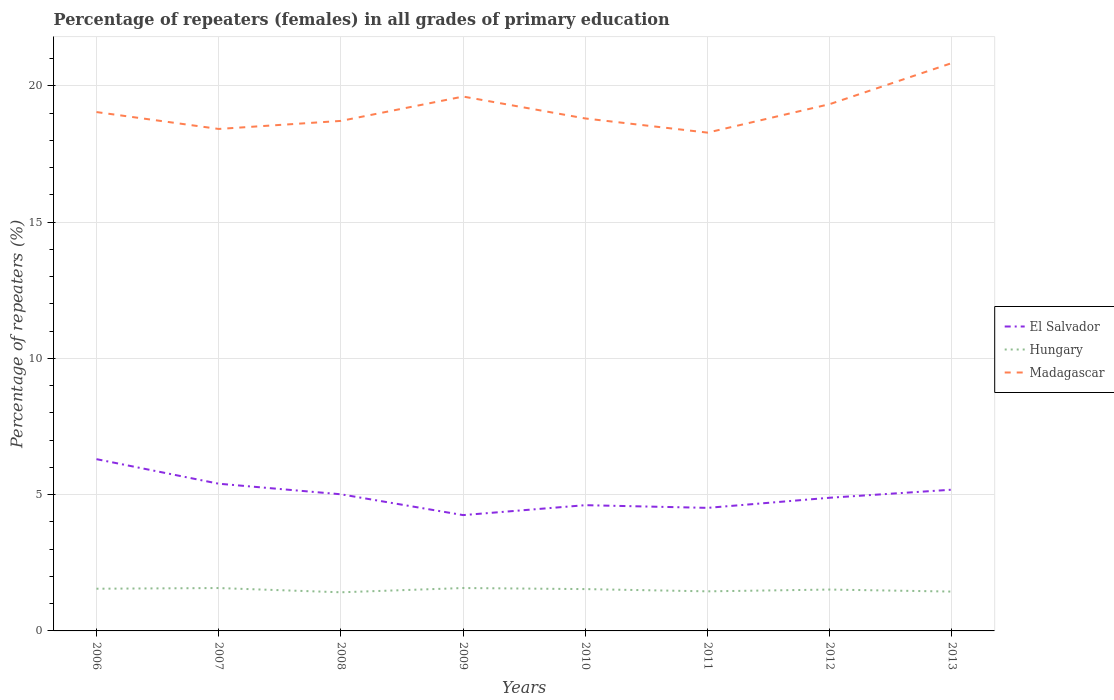Across all years, what is the maximum percentage of repeaters (females) in Hungary?
Provide a succinct answer. 1.42. In which year was the percentage of repeaters (females) in Madagascar maximum?
Give a very brief answer. 2011. What is the total percentage of repeaters (females) in El Salvador in the graph?
Your answer should be compact. 0.79. What is the difference between the highest and the second highest percentage of repeaters (females) in Hungary?
Your answer should be very brief. 0.16. Does the graph contain grids?
Offer a terse response. Yes. Where does the legend appear in the graph?
Make the answer very short. Center right. What is the title of the graph?
Give a very brief answer. Percentage of repeaters (females) in all grades of primary education. What is the label or title of the X-axis?
Give a very brief answer. Years. What is the label or title of the Y-axis?
Make the answer very short. Percentage of repeaters (%). What is the Percentage of repeaters (%) of El Salvador in 2006?
Provide a succinct answer. 6.3. What is the Percentage of repeaters (%) of Hungary in 2006?
Make the answer very short. 1.55. What is the Percentage of repeaters (%) of Madagascar in 2006?
Your answer should be very brief. 19.04. What is the Percentage of repeaters (%) of El Salvador in 2007?
Provide a succinct answer. 5.4. What is the Percentage of repeaters (%) of Hungary in 2007?
Provide a succinct answer. 1.57. What is the Percentage of repeaters (%) of Madagascar in 2007?
Your answer should be very brief. 18.42. What is the Percentage of repeaters (%) of El Salvador in 2008?
Give a very brief answer. 5.01. What is the Percentage of repeaters (%) of Hungary in 2008?
Offer a very short reply. 1.42. What is the Percentage of repeaters (%) in Madagascar in 2008?
Your answer should be compact. 18.71. What is the Percentage of repeaters (%) of El Salvador in 2009?
Keep it short and to the point. 4.25. What is the Percentage of repeaters (%) in Hungary in 2009?
Your answer should be very brief. 1.57. What is the Percentage of repeaters (%) of Madagascar in 2009?
Your answer should be very brief. 19.61. What is the Percentage of repeaters (%) of El Salvador in 2010?
Offer a terse response. 4.61. What is the Percentage of repeaters (%) in Hungary in 2010?
Ensure brevity in your answer.  1.53. What is the Percentage of repeaters (%) in Madagascar in 2010?
Keep it short and to the point. 18.8. What is the Percentage of repeaters (%) of El Salvador in 2011?
Provide a short and direct response. 4.52. What is the Percentage of repeaters (%) of Hungary in 2011?
Offer a terse response. 1.45. What is the Percentage of repeaters (%) in Madagascar in 2011?
Ensure brevity in your answer.  18.28. What is the Percentage of repeaters (%) of El Salvador in 2012?
Ensure brevity in your answer.  4.89. What is the Percentage of repeaters (%) in Hungary in 2012?
Offer a very short reply. 1.52. What is the Percentage of repeaters (%) in Madagascar in 2012?
Make the answer very short. 19.33. What is the Percentage of repeaters (%) in El Salvador in 2013?
Your answer should be compact. 5.18. What is the Percentage of repeaters (%) in Hungary in 2013?
Your answer should be compact. 1.44. What is the Percentage of repeaters (%) in Madagascar in 2013?
Offer a very short reply. 20.84. Across all years, what is the maximum Percentage of repeaters (%) in El Salvador?
Your answer should be very brief. 6.3. Across all years, what is the maximum Percentage of repeaters (%) of Hungary?
Ensure brevity in your answer.  1.57. Across all years, what is the maximum Percentage of repeaters (%) in Madagascar?
Offer a terse response. 20.84. Across all years, what is the minimum Percentage of repeaters (%) in El Salvador?
Give a very brief answer. 4.25. Across all years, what is the minimum Percentage of repeaters (%) in Hungary?
Give a very brief answer. 1.42. Across all years, what is the minimum Percentage of repeaters (%) of Madagascar?
Ensure brevity in your answer.  18.28. What is the total Percentage of repeaters (%) in El Salvador in the graph?
Provide a short and direct response. 40.17. What is the total Percentage of repeaters (%) of Hungary in the graph?
Provide a short and direct response. 12.06. What is the total Percentage of repeaters (%) of Madagascar in the graph?
Provide a succinct answer. 153.04. What is the difference between the Percentage of repeaters (%) of El Salvador in 2006 and that in 2007?
Your answer should be very brief. 0.9. What is the difference between the Percentage of repeaters (%) of Hungary in 2006 and that in 2007?
Your answer should be very brief. -0.02. What is the difference between the Percentage of repeaters (%) in Madagascar in 2006 and that in 2007?
Ensure brevity in your answer.  0.62. What is the difference between the Percentage of repeaters (%) of El Salvador in 2006 and that in 2008?
Your response must be concise. 1.29. What is the difference between the Percentage of repeaters (%) in Hungary in 2006 and that in 2008?
Your answer should be very brief. 0.13. What is the difference between the Percentage of repeaters (%) in Madagascar in 2006 and that in 2008?
Your answer should be very brief. 0.32. What is the difference between the Percentage of repeaters (%) in El Salvador in 2006 and that in 2009?
Your answer should be compact. 2.05. What is the difference between the Percentage of repeaters (%) in Hungary in 2006 and that in 2009?
Offer a very short reply. -0.03. What is the difference between the Percentage of repeaters (%) in Madagascar in 2006 and that in 2009?
Your response must be concise. -0.57. What is the difference between the Percentage of repeaters (%) in El Salvador in 2006 and that in 2010?
Make the answer very short. 1.69. What is the difference between the Percentage of repeaters (%) of Hungary in 2006 and that in 2010?
Ensure brevity in your answer.  0.01. What is the difference between the Percentage of repeaters (%) of Madagascar in 2006 and that in 2010?
Make the answer very short. 0.23. What is the difference between the Percentage of repeaters (%) of El Salvador in 2006 and that in 2011?
Offer a terse response. 1.79. What is the difference between the Percentage of repeaters (%) of Hungary in 2006 and that in 2011?
Offer a terse response. 0.1. What is the difference between the Percentage of repeaters (%) of Madagascar in 2006 and that in 2011?
Give a very brief answer. 0.75. What is the difference between the Percentage of repeaters (%) in El Salvador in 2006 and that in 2012?
Keep it short and to the point. 1.42. What is the difference between the Percentage of repeaters (%) in Hungary in 2006 and that in 2012?
Offer a very short reply. 0.03. What is the difference between the Percentage of repeaters (%) of Madagascar in 2006 and that in 2012?
Your answer should be compact. -0.29. What is the difference between the Percentage of repeaters (%) in El Salvador in 2006 and that in 2013?
Give a very brief answer. 1.12. What is the difference between the Percentage of repeaters (%) in Hungary in 2006 and that in 2013?
Your answer should be compact. 0.11. What is the difference between the Percentage of repeaters (%) of Madagascar in 2006 and that in 2013?
Provide a succinct answer. -1.8. What is the difference between the Percentage of repeaters (%) of El Salvador in 2007 and that in 2008?
Give a very brief answer. 0.39. What is the difference between the Percentage of repeaters (%) in Hungary in 2007 and that in 2008?
Your answer should be compact. 0.16. What is the difference between the Percentage of repeaters (%) of Madagascar in 2007 and that in 2008?
Your answer should be very brief. -0.3. What is the difference between the Percentage of repeaters (%) in El Salvador in 2007 and that in 2009?
Make the answer very short. 1.15. What is the difference between the Percentage of repeaters (%) of Hungary in 2007 and that in 2009?
Give a very brief answer. -0. What is the difference between the Percentage of repeaters (%) in Madagascar in 2007 and that in 2009?
Provide a succinct answer. -1.19. What is the difference between the Percentage of repeaters (%) of El Salvador in 2007 and that in 2010?
Offer a terse response. 0.79. What is the difference between the Percentage of repeaters (%) of Hungary in 2007 and that in 2010?
Give a very brief answer. 0.04. What is the difference between the Percentage of repeaters (%) of Madagascar in 2007 and that in 2010?
Offer a terse response. -0.38. What is the difference between the Percentage of repeaters (%) in El Salvador in 2007 and that in 2011?
Keep it short and to the point. 0.89. What is the difference between the Percentage of repeaters (%) of Hungary in 2007 and that in 2011?
Ensure brevity in your answer.  0.12. What is the difference between the Percentage of repeaters (%) in Madagascar in 2007 and that in 2011?
Provide a short and direct response. 0.13. What is the difference between the Percentage of repeaters (%) of El Salvador in 2007 and that in 2012?
Give a very brief answer. 0.51. What is the difference between the Percentage of repeaters (%) in Hungary in 2007 and that in 2012?
Provide a succinct answer. 0.06. What is the difference between the Percentage of repeaters (%) in Madagascar in 2007 and that in 2012?
Make the answer very short. -0.91. What is the difference between the Percentage of repeaters (%) in El Salvador in 2007 and that in 2013?
Your answer should be compact. 0.22. What is the difference between the Percentage of repeaters (%) of Hungary in 2007 and that in 2013?
Ensure brevity in your answer.  0.13. What is the difference between the Percentage of repeaters (%) in Madagascar in 2007 and that in 2013?
Give a very brief answer. -2.42. What is the difference between the Percentage of repeaters (%) of El Salvador in 2008 and that in 2009?
Provide a succinct answer. 0.76. What is the difference between the Percentage of repeaters (%) of Hungary in 2008 and that in 2009?
Your answer should be compact. -0.16. What is the difference between the Percentage of repeaters (%) in Madagascar in 2008 and that in 2009?
Offer a terse response. -0.89. What is the difference between the Percentage of repeaters (%) of El Salvador in 2008 and that in 2010?
Offer a terse response. 0.4. What is the difference between the Percentage of repeaters (%) of Hungary in 2008 and that in 2010?
Offer a very short reply. -0.12. What is the difference between the Percentage of repeaters (%) in Madagascar in 2008 and that in 2010?
Provide a short and direct response. -0.09. What is the difference between the Percentage of repeaters (%) of El Salvador in 2008 and that in 2011?
Your answer should be compact. 0.5. What is the difference between the Percentage of repeaters (%) in Hungary in 2008 and that in 2011?
Provide a short and direct response. -0.04. What is the difference between the Percentage of repeaters (%) of Madagascar in 2008 and that in 2011?
Your answer should be very brief. 0.43. What is the difference between the Percentage of repeaters (%) of El Salvador in 2008 and that in 2012?
Provide a short and direct response. 0.13. What is the difference between the Percentage of repeaters (%) of Hungary in 2008 and that in 2012?
Provide a succinct answer. -0.1. What is the difference between the Percentage of repeaters (%) in Madagascar in 2008 and that in 2012?
Make the answer very short. -0.61. What is the difference between the Percentage of repeaters (%) in El Salvador in 2008 and that in 2013?
Offer a terse response. -0.17. What is the difference between the Percentage of repeaters (%) of Hungary in 2008 and that in 2013?
Your response must be concise. -0.03. What is the difference between the Percentage of repeaters (%) of Madagascar in 2008 and that in 2013?
Offer a terse response. -2.12. What is the difference between the Percentage of repeaters (%) in El Salvador in 2009 and that in 2010?
Make the answer very short. -0.36. What is the difference between the Percentage of repeaters (%) of Hungary in 2009 and that in 2010?
Make the answer very short. 0.04. What is the difference between the Percentage of repeaters (%) in Madagascar in 2009 and that in 2010?
Keep it short and to the point. 0.8. What is the difference between the Percentage of repeaters (%) in El Salvador in 2009 and that in 2011?
Keep it short and to the point. -0.27. What is the difference between the Percentage of repeaters (%) in Hungary in 2009 and that in 2011?
Your answer should be very brief. 0.12. What is the difference between the Percentage of repeaters (%) of Madagascar in 2009 and that in 2011?
Provide a short and direct response. 1.32. What is the difference between the Percentage of repeaters (%) of El Salvador in 2009 and that in 2012?
Provide a succinct answer. -0.64. What is the difference between the Percentage of repeaters (%) of Hungary in 2009 and that in 2012?
Offer a very short reply. 0.06. What is the difference between the Percentage of repeaters (%) in Madagascar in 2009 and that in 2012?
Make the answer very short. 0.28. What is the difference between the Percentage of repeaters (%) of El Salvador in 2009 and that in 2013?
Offer a very short reply. -0.93. What is the difference between the Percentage of repeaters (%) of Hungary in 2009 and that in 2013?
Give a very brief answer. 0.13. What is the difference between the Percentage of repeaters (%) of Madagascar in 2009 and that in 2013?
Your response must be concise. -1.23. What is the difference between the Percentage of repeaters (%) in El Salvador in 2010 and that in 2011?
Your response must be concise. 0.1. What is the difference between the Percentage of repeaters (%) of Hungary in 2010 and that in 2011?
Your answer should be very brief. 0.08. What is the difference between the Percentage of repeaters (%) of Madagascar in 2010 and that in 2011?
Offer a terse response. 0.52. What is the difference between the Percentage of repeaters (%) in El Salvador in 2010 and that in 2012?
Provide a short and direct response. -0.27. What is the difference between the Percentage of repeaters (%) of Hungary in 2010 and that in 2012?
Offer a terse response. 0.02. What is the difference between the Percentage of repeaters (%) of Madagascar in 2010 and that in 2012?
Make the answer very short. -0.53. What is the difference between the Percentage of repeaters (%) of El Salvador in 2010 and that in 2013?
Your answer should be very brief. -0.57. What is the difference between the Percentage of repeaters (%) of Hungary in 2010 and that in 2013?
Offer a very short reply. 0.09. What is the difference between the Percentage of repeaters (%) of Madagascar in 2010 and that in 2013?
Your answer should be very brief. -2.03. What is the difference between the Percentage of repeaters (%) in El Salvador in 2011 and that in 2012?
Provide a short and direct response. -0.37. What is the difference between the Percentage of repeaters (%) in Hungary in 2011 and that in 2012?
Offer a very short reply. -0.07. What is the difference between the Percentage of repeaters (%) of Madagascar in 2011 and that in 2012?
Offer a terse response. -1.05. What is the difference between the Percentage of repeaters (%) of El Salvador in 2011 and that in 2013?
Make the answer very short. -0.67. What is the difference between the Percentage of repeaters (%) in Hungary in 2011 and that in 2013?
Provide a short and direct response. 0.01. What is the difference between the Percentage of repeaters (%) of Madagascar in 2011 and that in 2013?
Keep it short and to the point. -2.55. What is the difference between the Percentage of repeaters (%) in El Salvador in 2012 and that in 2013?
Provide a short and direct response. -0.3. What is the difference between the Percentage of repeaters (%) of Hungary in 2012 and that in 2013?
Offer a very short reply. 0.07. What is the difference between the Percentage of repeaters (%) in Madagascar in 2012 and that in 2013?
Keep it short and to the point. -1.51. What is the difference between the Percentage of repeaters (%) in El Salvador in 2006 and the Percentage of repeaters (%) in Hungary in 2007?
Your answer should be very brief. 4.73. What is the difference between the Percentage of repeaters (%) of El Salvador in 2006 and the Percentage of repeaters (%) of Madagascar in 2007?
Your answer should be compact. -12.12. What is the difference between the Percentage of repeaters (%) of Hungary in 2006 and the Percentage of repeaters (%) of Madagascar in 2007?
Your answer should be very brief. -16.87. What is the difference between the Percentage of repeaters (%) in El Salvador in 2006 and the Percentage of repeaters (%) in Hungary in 2008?
Make the answer very short. 4.89. What is the difference between the Percentage of repeaters (%) in El Salvador in 2006 and the Percentage of repeaters (%) in Madagascar in 2008?
Your answer should be very brief. -12.41. What is the difference between the Percentage of repeaters (%) in Hungary in 2006 and the Percentage of repeaters (%) in Madagascar in 2008?
Your response must be concise. -17.17. What is the difference between the Percentage of repeaters (%) of El Salvador in 2006 and the Percentage of repeaters (%) of Hungary in 2009?
Make the answer very short. 4.73. What is the difference between the Percentage of repeaters (%) of El Salvador in 2006 and the Percentage of repeaters (%) of Madagascar in 2009?
Offer a terse response. -13.31. What is the difference between the Percentage of repeaters (%) of Hungary in 2006 and the Percentage of repeaters (%) of Madagascar in 2009?
Keep it short and to the point. -18.06. What is the difference between the Percentage of repeaters (%) in El Salvador in 2006 and the Percentage of repeaters (%) in Hungary in 2010?
Keep it short and to the point. 4.77. What is the difference between the Percentage of repeaters (%) of El Salvador in 2006 and the Percentage of repeaters (%) of Madagascar in 2010?
Offer a very short reply. -12.5. What is the difference between the Percentage of repeaters (%) of Hungary in 2006 and the Percentage of repeaters (%) of Madagascar in 2010?
Your response must be concise. -17.26. What is the difference between the Percentage of repeaters (%) of El Salvador in 2006 and the Percentage of repeaters (%) of Hungary in 2011?
Ensure brevity in your answer.  4.85. What is the difference between the Percentage of repeaters (%) in El Salvador in 2006 and the Percentage of repeaters (%) in Madagascar in 2011?
Offer a terse response. -11.98. What is the difference between the Percentage of repeaters (%) of Hungary in 2006 and the Percentage of repeaters (%) of Madagascar in 2011?
Give a very brief answer. -16.74. What is the difference between the Percentage of repeaters (%) in El Salvador in 2006 and the Percentage of repeaters (%) in Hungary in 2012?
Offer a very short reply. 4.78. What is the difference between the Percentage of repeaters (%) of El Salvador in 2006 and the Percentage of repeaters (%) of Madagascar in 2012?
Offer a very short reply. -13.03. What is the difference between the Percentage of repeaters (%) in Hungary in 2006 and the Percentage of repeaters (%) in Madagascar in 2012?
Provide a short and direct response. -17.78. What is the difference between the Percentage of repeaters (%) in El Salvador in 2006 and the Percentage of repeaters (%) in Hungary in 2013?
Keep it short and to the point. 4.86. What is the difference between the Percentage of repeaters (%) of El Salvador in 2006 and the Percentage of repeaters (%) of Madagascar in 2013?
Offer a terse response. -14.54. What is the difference between the Percentage of repeaters (%) in Hungary in 2006 and the Percentage of repeaters (%) in Madagascar in 2013?
Make the answer very short. -19.29. What is the difference between the Percentage of repeaters (%) of El Salvador in 2007 and the Percentage of repeaters (%) of Hungary in 2008?
Your answer should be compact. 3.98. What is the difference between the Percentage of repeaters (%) in El Salvador in 2007 and the Percentage of repeaters (%) in Madagascar in 2008?
Keep it short and to the point. -13.31. What is the difference between the Percentage of repeaters (%) of Hungary in 2007 and the Percentage of repeaters (%) of Madagascar in 2008?
Keep it short and to the point. -17.14. What is the difference between the Percentage of repeaters (%) of El Salvador in 2007 and the Percentage of repeaters (%) of Hungary in 2009?
Offer a very short reply. 3.83. What is the difference between the Percentage of repeaters (%) in El Salvador in 2007 and the Percentage of repeaters (%) in Madagascar in 2009?
Ensure brevity in your answer.  -14.21. What is the difference between the Percentage of repeaters (%) of Hungary in 2007 and the Percentage of repeaters (%) of Madagascar in 2009?
Provide a succinct answer. -18.04. What is the difference between the Percentage of repeaters (%) in El Salvador in 2007 and the Percentage of repeaters (%) in Hungary in 2010?
Provide a short and direct response. 3.87. What is the difference between the Percentage of repeaters (%) of El Salvador in 2007 and the Percentage of repeaters (%) of Madagascar in 2010?
Your response must be concise. -13.4. What is the difference between the Percentage of repeaters (%) of Hungary in 2007 and the Percentage of repeaters (%) of Madagascar in 2010?
Your answer should be very brief. -17.23. What is the difference between the Percentage of repeaters (%) of El Salvador in 2007 and the Percentage of repeaters (%) of Hungary in 2011?
Your response must be concise. 3.95. What is the difference between the Percentage of repeaters (%) of El Salvador in 2007 and the Percentage of repeaters (%) of Madagascar in 2011?
Provide a succinct answer. -12.88. What is the difference between the Percentage of repeaters (%) of Hungary in 2007 and the Percentage of repeaters (%) of Madagascar in 2011?
Make the answer very short. -16.71. What is the difference between the Percentage of repeaters (%) of El Salvador in 2007 and the Percentage of repeaters (%) of Hungary in 2012?
Keep it short and to the point. 3.88. What is the difference between the Percentage of repeaters (%) in El Salvador in 2007 and the Percentage of repeaters (%) in Madagascar in 2012?
Ensure brevity in your answer.  -13.93. What is the difference between the Percentage of repeaters (%) in Hungary in 2007 and the Percentage of repeaters (%) in Madagascar in 2012?
Make the answer very short. -17.76. What is the difference between the Percentage of repeaters (%) in El Salvador in 2007 and the Percentage of repeaters (%) in Hungary in 2013?
Keep it short and to the point. 3.96. What is the difference between the Percentage of repeaters (%) in El Salvador in 2007 and the Percentage of repeaters (%) in Madagascar in 2013?
Your response must be concise. -15.44. What is the difference between the Percentage of repeaters (%) in Hungary in 2007 and the Percentage of repeaters (%) in Madagascar in 2013?
Your response must be concise. -19.26. What is the difference between the Percentage of repeaters (%) in El Salvador in 2008 and the Percentage of repeaters (%) in Hungary in 2009?
Provide a succinct answer. 3.44. What is the difference between the Percentage of repeaters (%) in El Salvador in 2008 and the Percentage of repeaters (%) in Madagascar in 2009?
Provide a short and direct response. -14.59. What is the difference between the Percentage of repeaters (%) in Hungary in 2008 and the Percentage of repeaters (%) in Madagascar in 2009?
Your answer should be very brief. -18.19. What is the difference between the Percentage of repeaters (%) of El Salvador in 2008 and the Percentage of repeaters (%) of Hungary in 2010?
Make the answer very short. 3.48. What is the difference between the Percentage of repeaters (%) of El Salvador in 2008 and the Percentage of repeaters (%) of Madagascar in 2010?
Your answer should be compact. -13.79. What is the difference between the Percentage of repeaters (%) of Hungary in 2008 and the Percentage of repeaters (%) of Madagascar in 2010?
Keep it short and to the point. -17.39. What is the difference between the Percentage of repeaters (%) in El Salvador in 2008 and the Percentage of repeaters (%) in Hungary in 2011?
Your answer should be very brief. 3.56. What is the difference between the Percentage of repeaters (%) in El Salvador in 2008 and the Percentage of repeaters (%) in Madagascar in 2011?
Your response must be concise. -13.27. What is the difference between the Percentage of repeaters (%) in Hungary in 2008 and the Percentage of repeaters (%) in Madagascar in 2011?
Ensure brevity in your answer.  -16.87. What is the difference between the Percentage of repeaters (%) of El Salvador in 2008 and the Percentage of repeaters (%) of Hungary in 2012?
Ensure brevity in your answer.  3.5. What is the difference between the Percentage of repeaters (%) in El Salvador in 2008 and the Percentage of repeaters (%) in Madagascar in 2012?
Your answer should be very brief. -14.32. What is the difference between the Percentage of repeaters (%) of Hungary in 2008 and the Percentage of repeaters (%) of Madagascar in 2012?
Provide a short and direct response. -17.91. What is the difference between the Percentage of repeaters (%) in El Salvador in 2008 and the Percentage of repeaters (%) in Hungary in 2013?
Give a very brief answer. 3.57. What is the difference between the Percentage of repeaters (%) of El Salvador in 2008 and the Percentage of repeaters (%) of Madagascar in 2013?
Give a very brief answer. -15.82. What is the difference between the Percentage of repeaters (%) of Hungary in 2008 and the Percentage of repeaters (%) of Madagascar in 2013?
Your response must be concise. -19.42. What is the difference between the Percentage of repeaters (%) in El Salvador in 2009 and the Percentage of repeaters (%) in Hungary in 2010?
Your answer should be very brief. 2.71. What is the difference between the Percentage of repeaters (%) in El Salvador in 2009 and the Percentage of repeaters (%) in Madagascar in 2010?
Provide a short and direct response. -14.55. What is the difference between the Percentage of repeaters (%) of Hungary in 2009 and the Percentage of repeaters (%) of Madagascar in 2010?
Your response must be concise. -17.23. What is the difference between the Percentage of repeaters (%) in El Salvador in 2009 and the Percentage of repeaters (%) in Hungary in 2011?
Keep it short and to the point. 2.8. What is the difference between the Percentage of repeaters (%) of El Salvador in 2009 and the Percentage of repeaters (%) of Madagascar in 2011?
Your answer should be compact. -14.03. What is the difference between the Percentage of repeaters (%) in Hungary in 2009 and the Percentage of repeaters (%) in Madagascar in 2011?
Keep it short and to the point. -16.71. What is the difference between the Percentage of repeaters (%) in El Salvador in 2009 and the Percentage of repeaters (%) in Hungary in 2012?
Your answer should be compact. 2.73. What is the difference between the Percentage of repeaters (%) of El Salvador in 2009 and the Percentage of repeaters (%) of Madagascar in 2012?
Offer a very short reply. -15.08. What is the difference between the Percentage of repeaters (%) in Hungary in 2009 and the Percentage of repeaters (%) in Madagascar in 2012?
Offer a terse response. -17.76. What is the difference between the Percentage of repeaters (%) of El Salvador in 2009 and the Percentage of repeaters (%) of Hungary in 2013?
Make the answer very short. 2.81. What is the difference between the Percentage of repeaters (%) of El Salvador in 2009 and the Percentage of repeaters (%) of Madagascar in 2013?
Provide a short and direct response. -16.59. What is the difference between the Percentage of repeaters (%) of Hungary in 2009 and the Percentage of repeaters (%) of Madagascar in 2013?
Keep it short and to the point. -19.26. What is the difference between the Percentage of repeaters (%) in El Salvador in 2010 and the Percentage of repeaters (%) in Hungary in 2011?
Offer a very short reply. 3.16. What is the difference between the Percentage of repeaters (%) in El Salvador in 2010 and the Percentage of repeaters (%) in Madagascar in 2011?
Provide a succinct answer. -13.67. What is the difference between the Percentage of repeaters (%) of Hungary in 2010 and the Percentage of repeaters (%) of Madagascar in 2011?
Provide a short and direct response. -16.75. What is the difference between the Percentage of repeaters (%) of El Salvador in 2010 and the Percentage of repeaters (%) of Hungary in 2012?
Your answer should be compact. 3.1. What is the difference between the Percentage of repeaters (%) of El Salvador in 2010 and the Percentage of repeaters (%) of Madagascar in 2012?
Offer a terse response. -14.72. What is the difference between the Percentage of repeaters (%) of Hungary in 2010 and the Percentage of repeaters (%) of Madagascar in 2012?
Make the answer very short. -17.79. What is the difference between the Percentage of repeaters (%) in El Salvador in 2010 and the Percentage of repeaters (%) in Hungary in 2013?
Your response must be concise. 3.17. What is the difference between the Percentage of repeaters (%) of El Salvador in 2010 and the Percentage of repeaters (%) of Madagascar in 2013?
Provide a short and direct response. -16.22. What is the difference between the Percentage of repeaters (%) of Hungary in 2010 and the Percentage of repeaters (%) of Madagascar in 2013?
Your response must be concise. -19.3. What is the difference between the Percentage of repeaters (%) in El Salvador in 2011 and the Percentage of repeaters (%) in Hungary in 2012?
Your response must be concise. 3. What is the difference between the Percentage of repeaters (%) of El Salvador in 2011 and the Percentage of repeaters (%) of Madagascar in 2012?
Ensure brevity in your answer.  -14.81. What is the difference between the Percentage of repeaters (%) in Hungary in 2011 and the Percentage of repeaters (%) in Madagascar in 2012?
Your answer should be compact. -17.88. What is the difference between the Percentage of repeaters (%) in El Salvador in 2011 and the Percentage of repeaters (%) in Hungary in 2013?
Make the answer very short. 3.07. What is the difference between the Percentage of repeaters (%) of El Salvador in 2011 and the Percentage of repeaters (%) of Madagascar in 2013?
Your response must be concise. -16.32. What is the difference between the Percentage of repeaters (%) of Hungary in 2011 and the Percentage of repeaters (%) of Madagascar in 2013?
Offer a terse response. -19.39. What is the difference between the Percentage of repeaters (%) in El Salvador in 2012 and the Percentage of repeaters (%) in Hungary in 2013?
Give a very brief answer. 3.44. What is the difference between the Percentage of repeaters (%) in El Salvador in 2012 and the Percentage of repeaters (%) in Madagascar in 2013?
Your answer should be compact. -15.95. What is the difference between the Percentage of repeaters (%) in Hungary in 2012 and the Percentage of repeaters (%) in Madagascar in 2013?
Provide a short and direct response. -19.32. What is the average Percentage of repeaters (%) of El Salvador per year?
Your answer should be very brief. 5.02. What is the average Percentage of repeaters (%) of Hungary per year?
Ensure brevity in your answer.  1.51. What is the average Percentage of repeaters (%) of Madagascar per year?
Offer a terse response. 19.13. In the year 2006, what is the difference between the Percentage of repeaters (%) of El Salvador and Percentage of repeaters (%) of Hungary?
Your answer should be compact. 4.75. In the year 2006, what is the difference between the Percentage of repeaters (%) in El Salvador and Percentage of repeaters (%) in Madagascar?
Keep it short and to the point. -12.74. In the year 2006, what is the difference between the Percentage of repeaters (%) of Hungary and Percentage of repeaters (%) of Madagascar?
Make the answer very short. -17.49. In the year 2007, what is the difference between the Percentage of repeaters (%) in El Salvador and Percentage of repeaters (%) in Hungary?
Offer a very short reply. 3.83. In the year 2007, what is the difference between the Percentage of repeaters (%) of El Salvador and Percentage of repeaters (%) of Madagascar?
Provide a short and direct response. -13.02. In the year 2007, what is the difference between the Percentage of repeaters (%) in Hungary and Percentage of repeaters (%) in Madagascar?
Ensure brevity in your answer.  -16.85. In the year 2008, what is the difference between the Percentage of repeaters (%) in El Salvador and Percentage of repeaters (%) in Hungary?
Provide a short and direct response. 3.6. In the year 2008, what is the difference between the Percentage of repeaters (%) in El Salvador and Percentage of repeaters (%) in Madagascar?
Your response must be concise. -13.7. In the year 2008, what is the difference between the Percentage of repeaters (%) in Hungary and Percentage of repeaters (%) in Madagascar?
Offer a terse response. -17.3. In the year 2009, what is the difference between the Percentage of repeaters (%) of El Salvador and Percentage of repeaters (%) of Hungary?
Your answer should be very brief. 2.68. In the year 2009, what is the difference between the Percentage of repeaters (%) of El Salvador and Percentage of repeaters (%) of Madagascar?
Offer a terse response. -15.36. In the year 2009, what is the difference between the Percentage of repeaters (%) of Hungary and Percentage of repeaters (%) of Madagascar?
Your answer should be very brief. -18.03. In the year 2010, what is the difference between the Percentage of repeaters (%) of El Salvador and Percentage of repeaters (%) of Hungary?
Make the answer very short. 3.08. In the year 2010, what is the difference between the Percentage of repeaters (%) in El Salvador and Percentage of repeaters (%) in Madagascar?
Keep it short and to the point. -14.19. In the year 2010, what is the difference between the Percentage of repeaters (%) of Hungary and Percentage of repeaters (%) of Madagascar?
Offer a terse response. -17.27. In the year 2011, what is the difference between the Percentage of repeaters (%) of El Salvador and Percentage of repeaters (%) of Hungary?
Ensure brevity in your answer.  3.06. In the year 2011, what is the difference between the Percentage of repeaters (%) in El Salvador and Percentage of repeaters (%) in Madagascar?
Keep it short and to the point. -13.77. In the year 2011, what is the difference between the Percentage of repeaters (%) in Hungary and Percentage of repeaters (%) in Madagascar?
Your answer should be compact. -16.83. In the year 2012, what is the difference between the Percentage of repeaters (%) of El Salvador and Percentage of repeaters (%) of Hungary?
Ensure brevity in your answer.  3.37. In the year 2012, what is the difference between the Percentage of repeaters (%) in El Salvador and Percentage of repeaters (%) in Madagascar?
Your response must be concise. -14.44. In the year 2012, what is the difference between the Percentage of repeaters (%) of Hungary and Percentage of repeaters (%) of Madagascar?
Your response must be concise. -17.81. In the year 2013, what is the difference between the Percentage of repeaters (%) of El Salvador and Percentage of repeaters (%) of Hungary?
Ensure brevity in your answer.  3.74. In the year 2013, what is the difference between the Percentage of repeaters (%) of El Salvador and Percentage of repeaters (%) of Madagascar?
Ensure brevity in your answer.  -15.66. In the year 2013, what is the difference between the Percentage of repeaters (%) of Hungary and Percentage of repeaters (%) of Madagascar?
Offer a very short reply. -19.39. What is the ratio of the Percentage of repeaters (%) of El Salvador in 2006 to that in 2007?
Offer a very short reply. 1.17. What is the ratio of the Percentage of repeaters (%) in Hungary in 2006 to that in 2007?
Ensure brevity in your answer.  0.98. What is the ratio of the Percentage of repeaters (%) in Madagascar in 2006 to that in 2007?
Your answer should be compact. 1.03. What is the ratio of the Percentage of repeaters (%) of El Salvador in 2006 to that in 2008?
Offer a very short reply. 1.26. What is the ratio of the Percentage of repeaters (%) of Hungary in 2006 to that in 2008?
Keep it short and to the point. 1.09. What is the ratio of the Percentage of repeaters (%) of Madagascar in 2006 to that in 2008?
Make the answer very short. 1.02. What is the ratio of the Percentage of repeaters (%) in El Salvador in 2006 to that in 2009?
Make the answer very short. 1.48. What is the ratio of the Percentage of repeaters (%) in Hungary in 2006 to that in 2009?
Make the answer very short. 0.98. What is the ratio of the Percentage of repeaters (%) of Madagascar in 2006 to that in 2009?
Provide a short and direct response. 0.97. What is the ratio of the Percentage of repeaters (%) in El Salvador in 2006 to that in 2010?
Offer a very short reply. 1.37. What is the ratio of the Percentage of repeaters (%) of Madagascar in 2006 to that in 2010?
Give a very brief answer. 1.01. What is the ratio of the Percentage of repeaters (%) in El Salvador in 2006 to that in 2011?
Keep it short and to the point. 1.4. What is the ratio of the Percentage of repeaters (%) in Hungary in 2006 to that in 2011?
Offer a terse response. 1.07. What is the ratio of the Percentage of repeaters (%) in Madagascar in 2006 to that in 2011?
Your answer should be very brief. 1.04. What is the ratio of the Percentage of repeaters (%) in El Salvador in 2006 to that in 2012?
Your answer should be compact. 1.29. What is the ratio of the Percentage of repeaters (%) of Hungary in 2006 to that in 2012?
Offer a terse response. 1.02. What is the ratio of the Percentage of repeaters (%) of El Salvador in 2006 to that in 2013?
Your response must be concise. 1.22. What is the ratio of the Percentage of repeaters (%) of Hungary in 2006 to that in 2013?
Your answer should be very brief. 1.07. What is the ratio of the Percentage of repeaters (%) in Madagascar in 2006 to that in 2013?
Keep it short and to the point. 0.91. What is the ratio of the Percentage of repeaters (%) in El Salvador in 2007 to that in 2008?
Provide a short and direct response. 1.08. What is the ratio of the Percentage of repeaters (%) in Hungary in 2007 to that in 2008?
Your response must be concise. 1.11. What is the ratio of the Percentage of repeaters (%) in Madagascar in 2007 to that in 2008?
Give a very brief answer. 0.98. What is the ratio of the Percentage of repeaters (%) in El Salvador in 2007 to that in 2009?
Your response must be concise. 1.27. What is the ratio of the Percentage of repeaters (%) in Madagascar in 2007 to that in 2009?
Your answer should be compact. 0.94. What is the ratio of the Percentage of repeaters (%) of El Salvador in 2007 to that in 2010?
Give a very brief answer. 1.17. What is the ratio of the Percentage of repeaters (%) in Hungary in 2007 to that in 2010?
Provide a short and direct response. 1.02. What is the ratio of the Percentage of repeaters (%) in Madagascar in 2007 to that in 2010?
Your answer should be very brief. 0.98. What is the ratio of the Percentage of repeaters (%) of El Salvador in 2007 to that in 2011?
Give a very brief answer. 1.2. What is the ratio of the Percentage of repeaters (%) in Hungary in 2007 to that in 2011?
Your answer should be compact. 1.08. What is the ratio of the Percentage of repeaters (%) of Madagascar in 2007 to that in 2011?
Provide a short and direct response. 1.01. What is the ratio of the Percentage of repeaters (%) in El Salvador in 2007 to that in 2012?
Your response must be concise. 1.11. What is the ratio of the Percentage of repeaters (%) of Hungary in 2007 to that in 2012?
Provide a succinct answer. 1.04. What is the ratio of the Percentage of repeaters (%) in Madagascar in 2007 to that in 2012?
Your response must be concise. 0.95. What is the ratio of the Percentage of repeaters (%) of El Salvador in 2007 to that in 2013?
Offer a terse response. 1.04. What is the ratio of the Percentage of repeaters (%) in Hungary in 2007 to that in 2013?
Keep it short and to the point. 1.09. What is the ratio of the Percentage of repeaters (%) in Madagascar in 2007 to that in 2013?
Ensure brevity in your answer.  0.88. What is the ratio of the Percentage of repeaters (%) of El Salvador in 2008 to that in 2009?
Ensure brevity in your answer.  1.18. What is the ratio of the Percentage of repeaters (%) of Hungary in 2008 to that in 2009?
Give a very brief answer. 0.9. What is the ratio of the Percentage of repeaters (%) in Madagascar in 2008 to that in 2009?
Your answer should be very brief. 0.95. What is the ratio of the Percentage of repeaters (%) of El Salvador in 2008 to that in 2010?
Give a very brief answer. 1.09. What is the ratio of the Percentage of repeaters (%) of Hungary in 2008 to that in 2010?
Your answer should be compact. 0.92. What is the ratio of the Percentage of repeaters (%) of El Salvador in 2008 to that in 2011?
Your answer should be compact. 1.11. What is the ratio of the Percentage of repeaters (%) in Hungary in 2008 to that in 2011?
Your answer should be compact. 0.98. What is the ratio of the Percentage of repeaters (%) of Madagascar in 2008 to that in 2011?
Your answer should be compact. 1.02. What is the ratio of the Percentage of repeaters (%) of El Salvador in 2008 to that in 2012?
Ensure brevity in your answer.  1.03. What is the ratio of the Percentage of repeaters (%) of Hungary in 2008 to that in 2012?
Provide a succinct answer. 0.93. What is the ratio of the Percentage of repeaters (%) in Madagascar in 2008 to that in 2012?
Keep it short and to the point. 0.97. What is the ratio of the Percentage of repeaters (%) of El Salvador in 2008 to that in 2013?
Keep it short and to the point. 0.97. What is the ratio of the Percentage of repeaters (%) in Hungary in 2008 to that in 2013?
Ensure brevity in your answer.  0.98. What is the ratio of the Percentage of repeaters (%) of Madagascar in 2008 to that in 2013?
Offer a very short reply. 0.9. What is the ratio of the Percentage of repeaters (%) in El Salvador in 2009 to that in 2010?
Ensure brevity in your answer.  0.92. What is the ratio of the Percentage of repeaters (%) of Hungary in 2009 to that in 2010?
Offer a very short reply. 1.03. What is the ratio of the Percentage of repeaters (%) of Madagascar in 2009 to that in 2010?
Your answer should be compact. 1.04. What is the ratio of the Percentage of repeaters (%) of Hungary in 2009 to that in 2011?
Your response must be concise. 1.08. What is the ratio of the Percentage of repeaters (%) of Madagascar in 2009 to that in 2011?
Your answer should be compact. 1.07. What is the ratio of the Percentage of repeaters (%) in El Salvador in 2009 to that in 2012?
Keep it short and to the point. 0.87. What is the ratio of the Percentage of repeaters (%) in Hungary in 2009 to that in 2012?
Offer a very short reply. 1.04. What is the ratio of the Percentage of repeaters (%) in Madagascar in 2009 to that in 2012?
Ensure brevity in your answer.  1.01. What is the ratio of the Percentage of repeaters (%) of El Salvador in 2009 to that in 2013?
Your answer should be compact. 0.82. What is the ratio of the Percentage of repeaters (%) of Hungary in 2009 to that in 2013?
Your response must be concise. 1.09. What is the ratio of the Percentage of repeaters (%) in Madagascar in 2009 to that in 2013?
Ensure brevity in your answer.  0.94. What is the ratio of the Percentage of repeaters (%) in El Salvador in 2010 to that in 2011?
Offer a very short reply. 1.02. What is the ratio of the Percentage of repeaters (%) in Hungary in 2010 to that in 2011?
Your answer should be very brief. 1.06. What is the ratio of the Percentage of repeaters (%) of Madagascar in 2010 to that in 2011?
Keep it short and to the point. 1.03. What is the ratio of the Percentage of repeaters (%) of El Salvador in 2010 to that in 2012?
Your response must be concise. 0.94. What is the ratio of the Percentage of repeaters (%) of Hungary in 2010 to that in 2012?
Offer a terse response. 1.01. What is the ratio of the Percentage of repeaters (%) in Madagascar in 2010 to that in 2012?
Offer a very short reply. 0.97. What is the ratio of the Percentage of repeaters (%) of El Salvador in 2010 to that in 2013?
Your answer should be compact. 0.89. What is the ratio of the Percentage of repeaters (%) in Hungary in 2010 to that in 2013?
Your answer should be compact. 1.06. What is the ratio of the Percentage of repeaters (%) in Madagascar in 2010 to that in 2013?
Offer a very short reply. 0.9. What is the ratio of the Percentage of repeaters (%) in El Salvador in 2011 to that in 2012?
Provide a succinct answer. 0.92. What is the ratio of the Percentage of repeaters (%) of Hungary in 2011 to that in 2012?
Keep it short and to the point. 0.96. What is the ratio of the Percentage of repeaters (%) of Madagascar in 2011 to that in 2012?
Your answer should be very brief. 0.95. What is the ratio of the Percentage of repeaters (%) in El Salvador in 2011 to that in 2013?
Your answer should be compact. 0.87. What is the ratio of the Percentage of repeaters (%) of Madagascar in 2011 to that in 2013?
Provide a succinct answer. 0.88. What is the ratio of the Percentage of repeaters (%) of El Salvador in 2012 to that in 2013?
Provide a short and direct response. 0.94. What is the ratio of the Percentage of repeaters (%) in Hungary in 2012 to that in 2013?
Your answer should be compact. 1.05. What is the ratio of the Percentage of repeaters (%) in Madagascar in 2012 to that in 2013?
Offer a very short reply. 0.93. What is the difference between the highest and the second highest Percentage of repeaters (%) of El Salvador?
Your answer should be very brief. 0.9. What is the difference between the highest and the second highest Percentage of repeaters (%) of Hungary?
Offer a terse response. 0. What is the difference between the highest and the second highest Percentage of repeaters (%) of Madagascar?
Keep it short and to the point. 1.23. What is the difference between the highest and the lowest Percentage of repeaters (%) of El Salvador?
Make the answer very short. 2.05. What is the difference between the highest and the lowest Percentage of repeaters (%) in Hungary?
Give a very brief answer. 0.16. What is the difference between the highest and the lowest Percentage of repeaters (%) of Madagascar?
Provide a short and direct response. 2.55. 